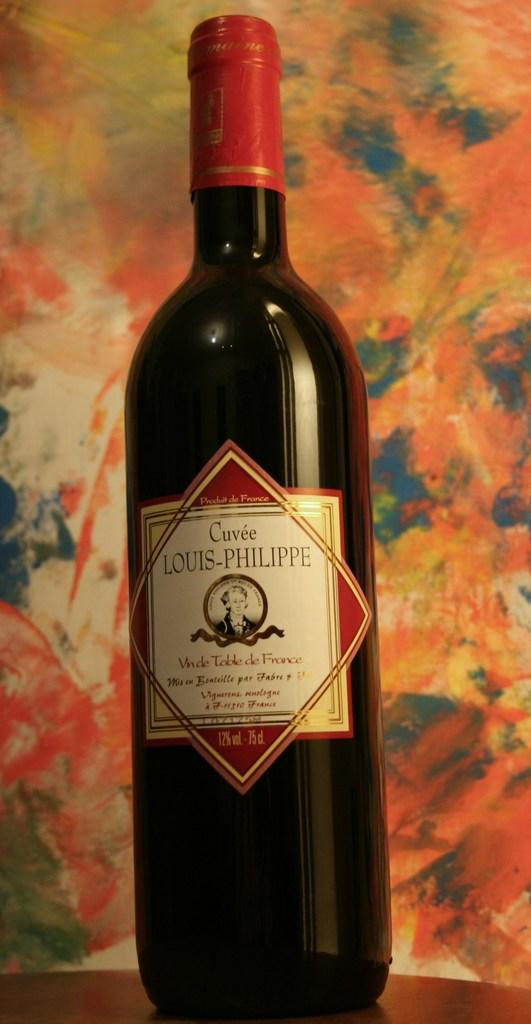<image>
Give a short and clear explanation of the subsequent image. a bottle of Cuve Louis-Philippe is sitting on a table 